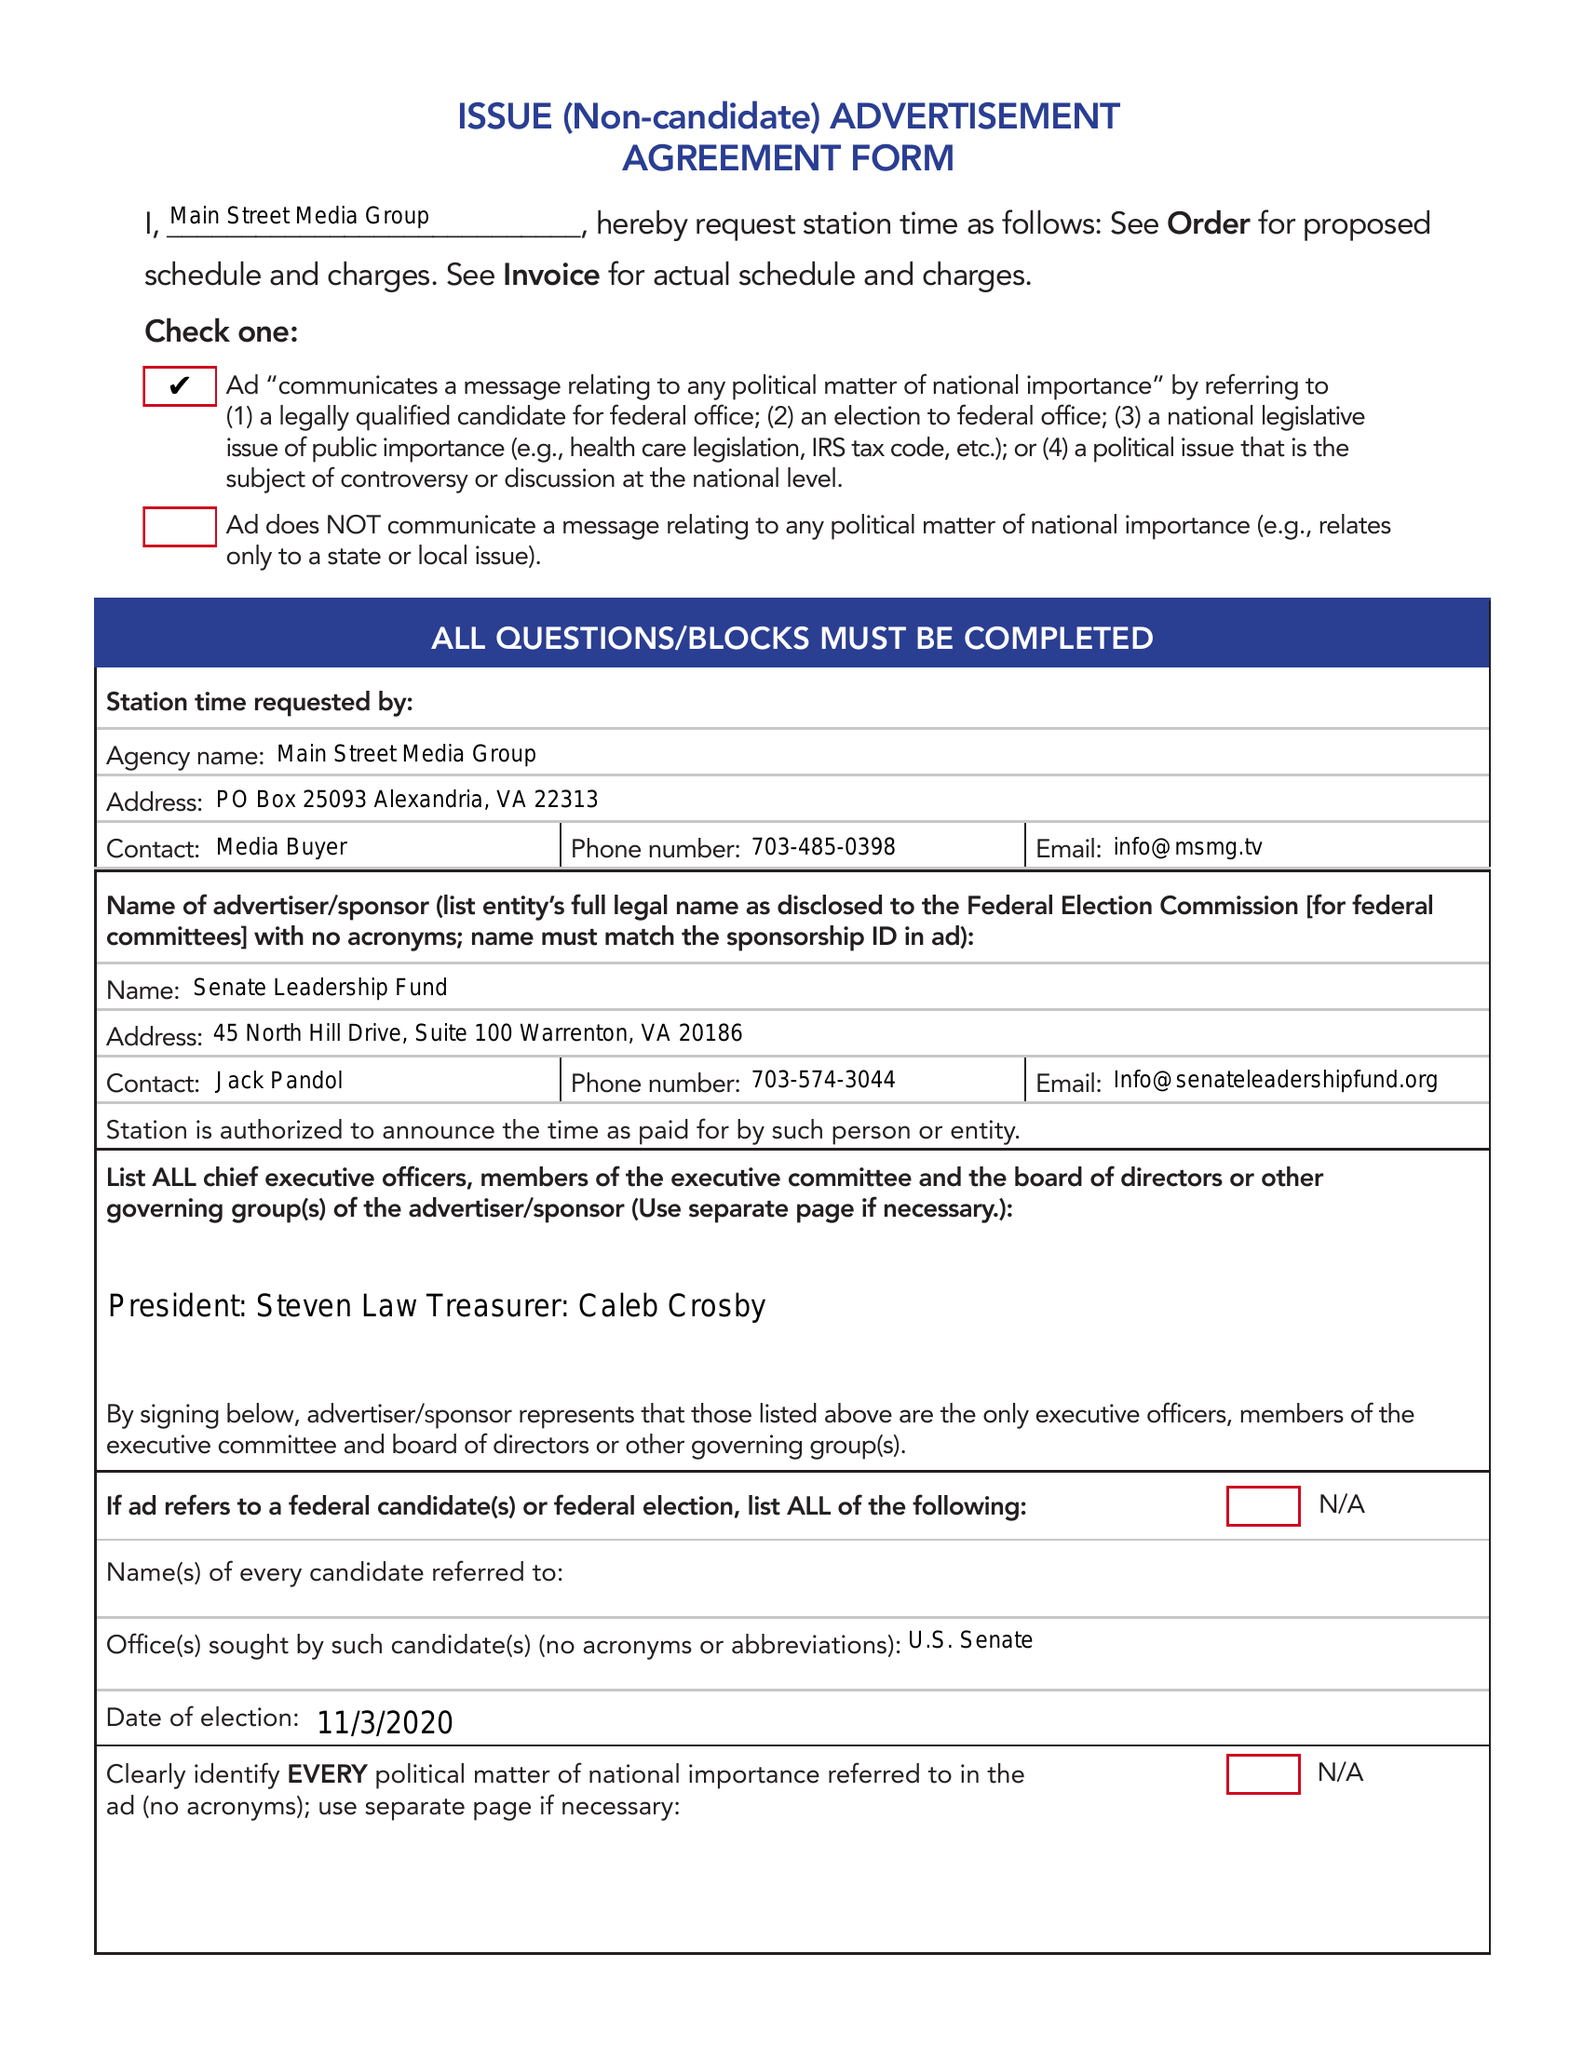What is the value for the advertiser?
Answer the question using a single word or phrase. SENATE LEADERSHIP FUND 